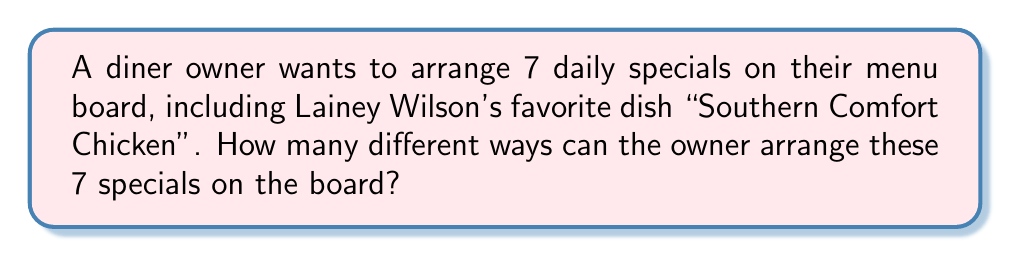Solve this math problem. Let's approach this step-by-step:

1) This is a permutation problem. We need to arrange 7 items in a specific order.

2) In permutations, the order matters. For example, having "Southern Comfort Chicken" first is different from having it last.

3) We are using all 7 specials, and each special can only be used once.

4) The formula for permutations of n distinct objects is:

   $$P(n) = n!$$

   Where $n!$ represents the factorial of $n$.

5) In this case, $n = 7$, so we need to calculate $7!$

6) Let's expand this:

   $$7! = 7 \times 6 \times 5 \times 4 \times 3 \times 2 \times 1$$

7) Calculating this out:

   $$7! = 5040$$

Therefore, there are 5040 different ways to arrange the 7 daily specials on the menu board.
Answer: 5040 